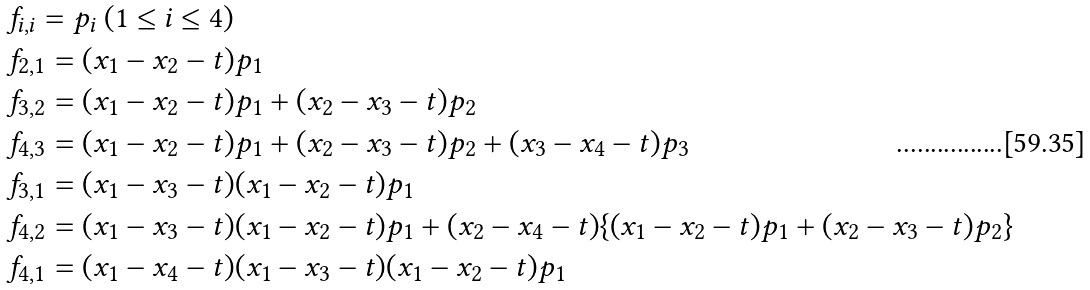Convert formula to latex. <formula><loc_0><loc_0><loc_500><loc_500>& f _ { i , i } = p _ { i } \ ( 1 \leq i \leq 4 ) \\ & f _ { 2 , 1 } = ( x _ { 1 } - x _ { 2 } - t ) p _ { 1 } \\ & f _ { 3 , 2 } = ( x _ { 1 } - x _ { 2 } - t ) p _ { 1 } + ( x _ { 2 } - x _ { 3 } - t ) p _ { 2 } \\ & f _ { 4 , 3 } = ( x _ { 1 } - x _ { 2 } - t ) p _ { 1 } + ( x _ { 2 } - x _ { 3 } - t ) p _ { 2 } + ( x _ { 3 } - x _ { 4 } - t ) p _ { 3 } \\ & f _ { 3 , 1 } = ( x _ { 1 } - x _ { 3 } - t ) ( x _ { 1 } - x _ { 2 } - t ) p _ { 1 } \\ & f _ { 4 , 2 } = ( x _ { 1 } - x _ { 3 } - t ) ( x _ { 1 } - x _ { 2 } - t ) p _ { 1 } + ( x _ { 2 } - x _ { 4 } - t ) \{ ( x _ { 1 } - x _ { 2 } - t ) p _ { 1 } + ( x _ { 2 } - x _ { 3 } - t ) p _ { 2 } \} \\ & f _ { 4 , 1 } = ( x _ { 1 } - x _ { 4 } - t ) ( x _ { 1 } - x _ { 3 } - t ) ( x _ { 1 } - x _ { 2 } - t ) p _ { 1 }</formula> 